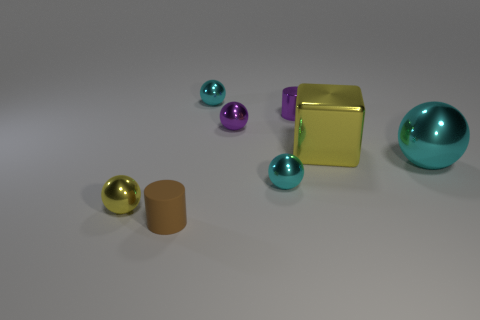Does the small thing behind the purple cylinder have the same shape as the yellow metallic thing that is to the left of the tiny metallic cylinder?
Provide a short and direct response. Yes. The rubber cylinder has what color?
Your response must be concise. Brown. How many matte things are either things or small red objects?
Provide a succinct answer. 1. There is another tiny object that is the same shape as the tiny brown rubber object; what is its color?
Your response must be concise. Purple. Is there a small purple matte cube?
Ensure brevity in your answer.  No. Does the purple object that is in front of the purple metal cylinder have the same material as the tiny cylinder in front of the large metallic sphere?
Provide a succinct answer. No. There is a shiny thing that is the same color as the tiny metallic cylinder; what is its shape?
Provide a short and direct response. Sphere. How many objects are either cyan shiny spheres in front of the purple sphere or metallic spheres that are on the right side of the tiny matte cylinder?
Provide a succinct answer. 4. Does the ball behind the purple cylinder have the same color as the ball right of the purple cylinder?
Your answer should be compact. Yes. There is a object that is on the right side of the small purple ball and behind the big yellow shiny object; what is its shape?
Your response must be concise. Cylinder. 